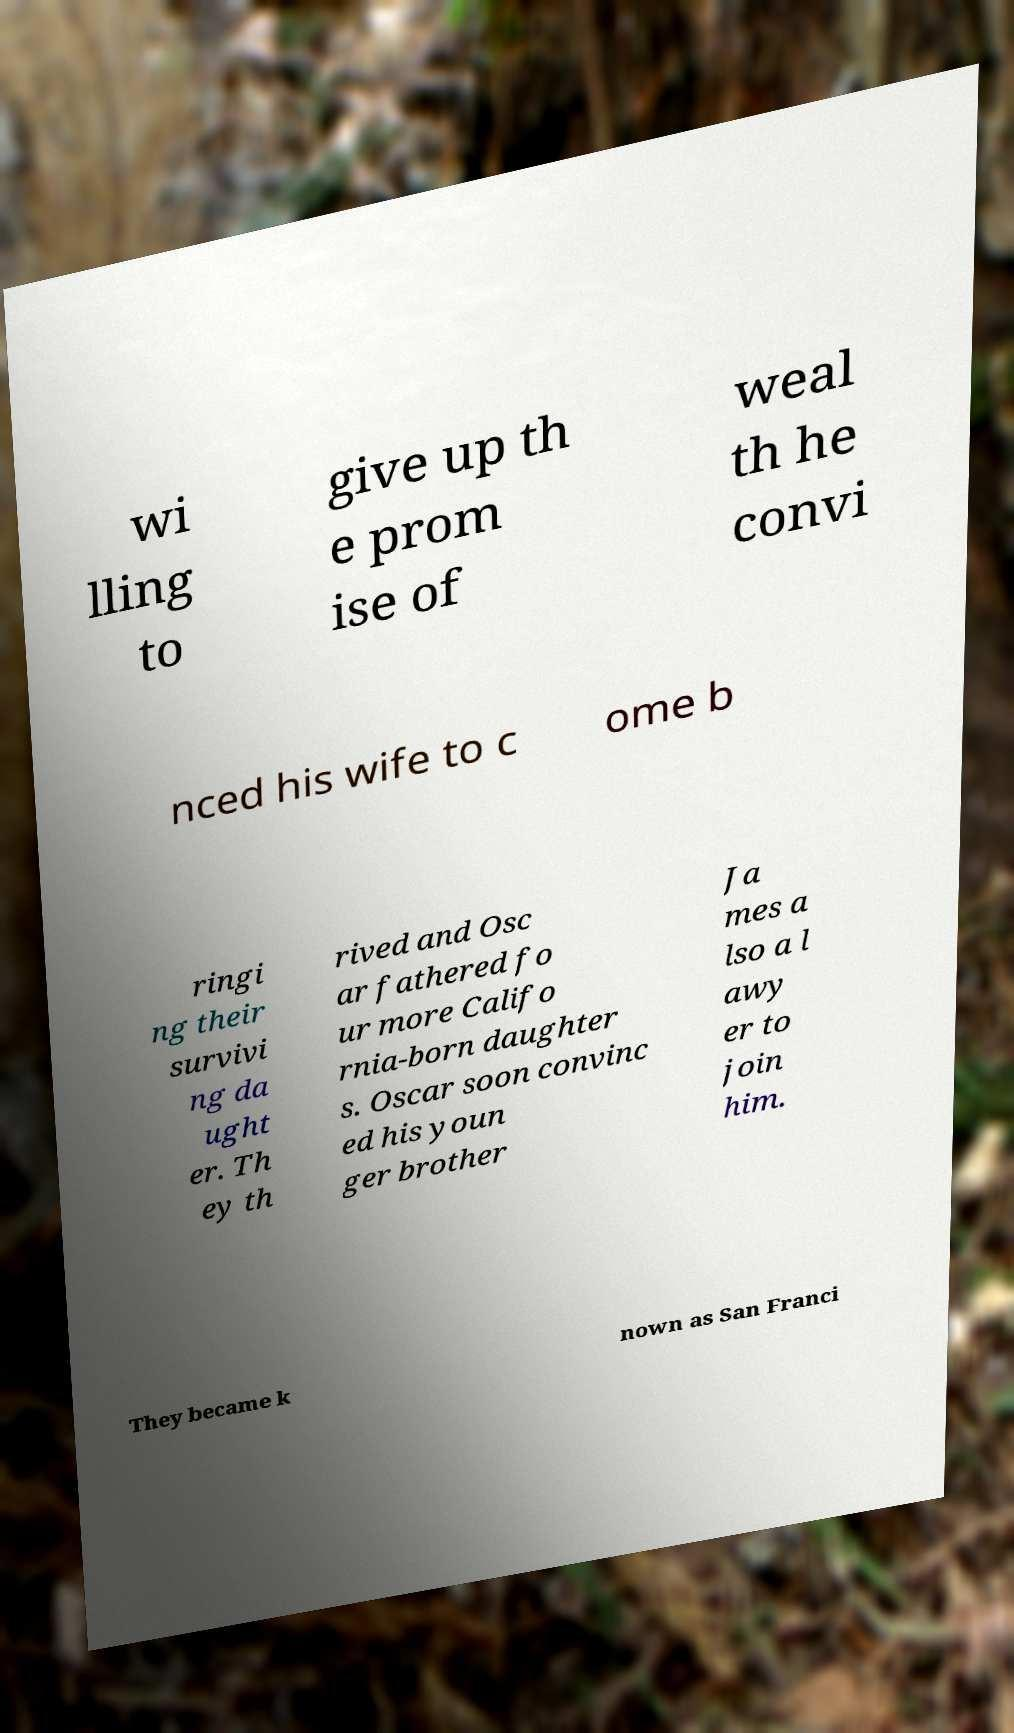Could you assist in decoding the text presented in this image and type it out clearly? wi lling to give up th e prom ise of weal th he convi nced his wife to c ome b ringi ng their survivi ng da ught er. Th ey th rived and Osc ar fathered fo ur more Califo rnia-born daughter s. Oscar soon convinc ed his youn ger brother Ja mes a lso a l awy er to join him. They became k nown as San Franci 